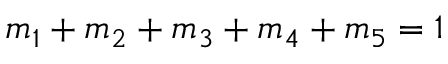<formula> <loc_0><loc_0><loc_500><loc_500>\begin{array} { r } { m _ { 1 } + m _ { 2 } + m _ { 3 } + m _ { 4 } + m _ { 5 } = 1 } \end{array}</formula> 